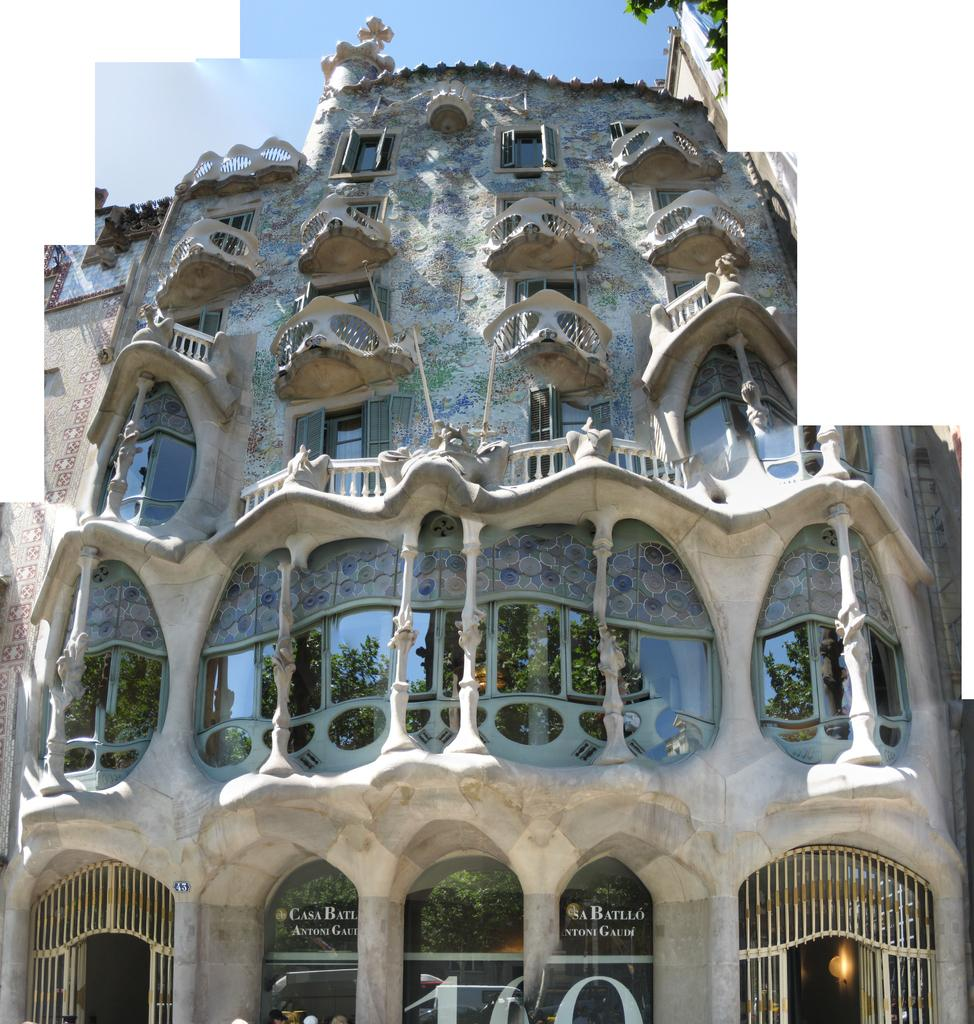What structure is present in the image? There is a building in the image. What is visible at the top of the image? The sky is visible at the top of the image. What type of learning can be observed taking place in the building in the image? There is no indication of any learning taking place in the building in the image. 